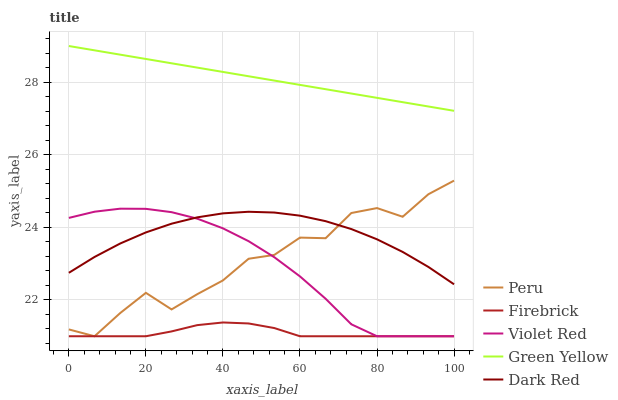Does Firebrick have the minimum area under the curve?
Answer yes or no. Yes. Does Green Yellow have the maximum area under the curve?
Answer yes or no. Yes. Does Green Yellow have the minimum area under the curve?
Answer yes or no. No. Does Firebrick have the maximum area under the curve?
Answer yes or no. No. Is Green Yellow the smoothest?
Answer yes or no. Yes. Is Peru the roughest?
Answer yes or no. Yes. Is Firebrick the smoothest?
Answer yes or no. No. Is Firebrick the roughest?
Answer yes or no. No. Does Firebrick have the lowest value?
Answer yes or no. Yes. Does Green Yellow have the lowest value?
Answer yes or no. No. Does Green Yellow have the highest value?
Answer yes or no. Yes. Does Firebrick have the highest value?
Answer yes or no. No. Is Peru less than Green Yellow?
Answer yes or no. Yes. Is Green Yellow greater than Peru?
Answer yes or no. Yes. Does Peru intersect Dark Red?
Answer yes or no. Yes. Is Peru less than Dark Red?
Answer yes or no. No. Is Peru greater than Dark Red?
Answer yes or no. No. Does Peru intersect Green Yellow?
Answer yes or no. No. 